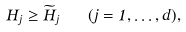<formula> <loc_0><loc_0><loc_500><loc_500>H _ { j } \geq \widetilde { H } _ { j } \quad ( j = 1 , \dots , d ) ,</formula> 